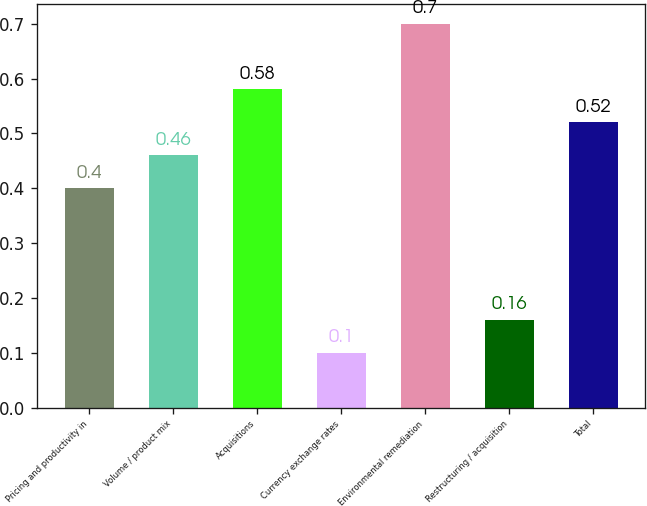Convert chart to OTSL. <chart><loc_0><loc_0><loc_500><loc_500><bar_chart><fcel>Pricing and productivity in<fcel>Volume / product mix<fcel>Acquisitions<fcel>Currency exchange rates<fcel>Environmental remediation<fcel>Restructuring / acquisition<fcel>Total<nl><fcel>0.4<fcel>0.46<fcel>0.58<fcel>0.1<fcel>0.7<fcel>0.16<fcel>0.52<nl></chart> 